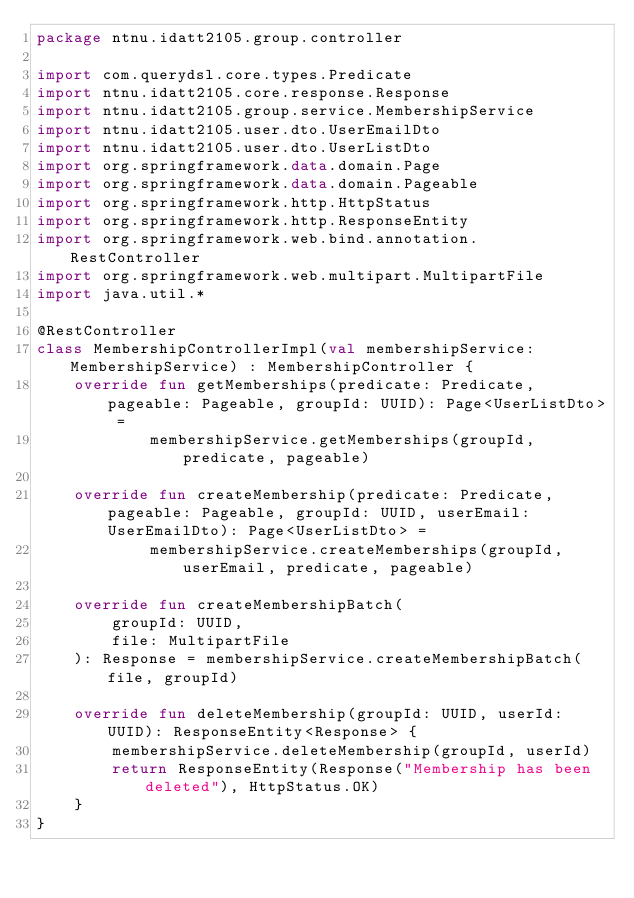Convert code to text. <code><loc_0><loc_0><loc_500><loc_500><_Kotlin_>package ntnu.idatt2105.group.controller

import com.querydsl.core.types.Predicate
import ntnu.idatt2105.core.response.Response
import ntnu.idatt2105.group.service.MembershipService
import ntnu.idatt2105.user.dto.UserEmailDto
import ntnu.idatt2105.user.dto.UserListDto
import org.springframework.data.domain.Page
import org.springframework.data.domain.Pageable
import org.springframework.http.HttpStatus
import org.springframework.http.ResponseEntity
import org.springframework.web.bind.annotation.RestController
import org.springframework.web.multipart.MultipartFile
import java.util.*

@RestController
class MembershipControllerImpl(val membershipService: MembershipService) : MembershipController {
    override fun getMemberships(predicate: Predicate, pageable: Pageable, groupId: UUID): Page<UserListDto> =
            membershipService.getMemberships(groupId, predicate, pageable)

    override fun createMembership(predicate: Predicate, pageable: Pageable, groupId: UUID, userEmail: UserEmailDto): Page<UserListDto> =
            membershipService.createMemberships(groupId, userEmail, predicate, pageable)

    override fun createMembershipBatch(
        groupId: UUID,
        file: MultipartFile
    ): Response = membershipService.createMembershipBatch(file, groupId)

    override fun deleteMembership(groupId: UUID, userId: UUID): ResponseEntity<Response> {
        membershipService.deleteMembership(groupId, userId)
        return ResponseEntity(Response("Membership has been deleted"), HttpStatus.OK)
    }
}
</code> 